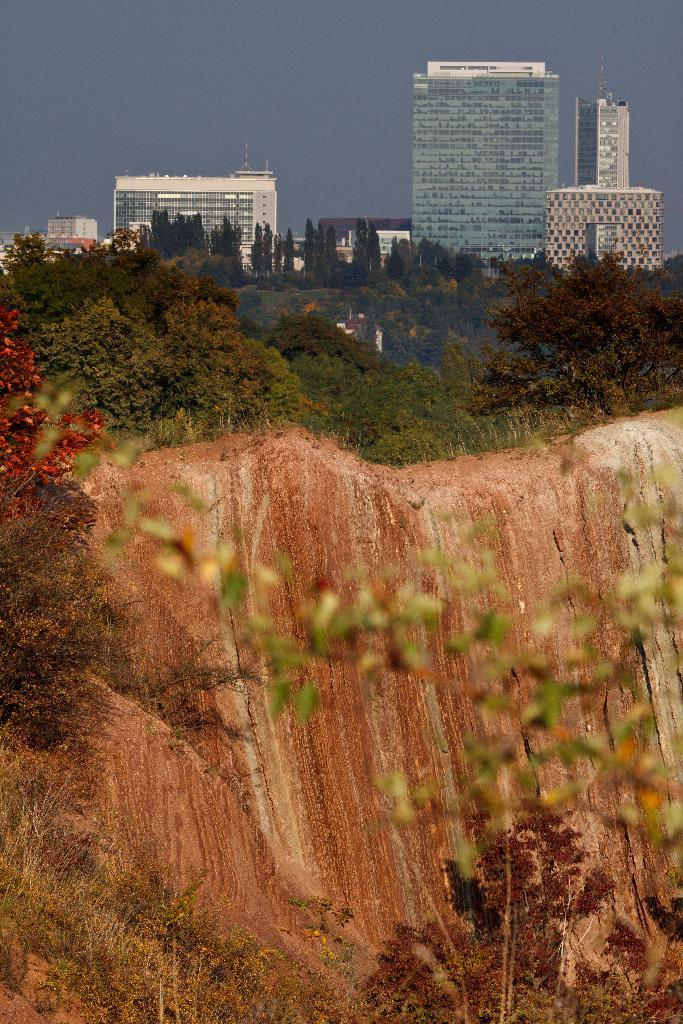What type of natural vegetation is present in the image? There are trees in the image. What type of geological formation can be seen in the image? There are rocks in the image. What type of man-made structures are visible in the image? There are buildings in the image. How much debt do the brothers owe in the image? There are no brothers or any mention of debt present in the image. What type of military vehicle can be seen in the image? There is no military vehicle, such as a tank, present in the image. 